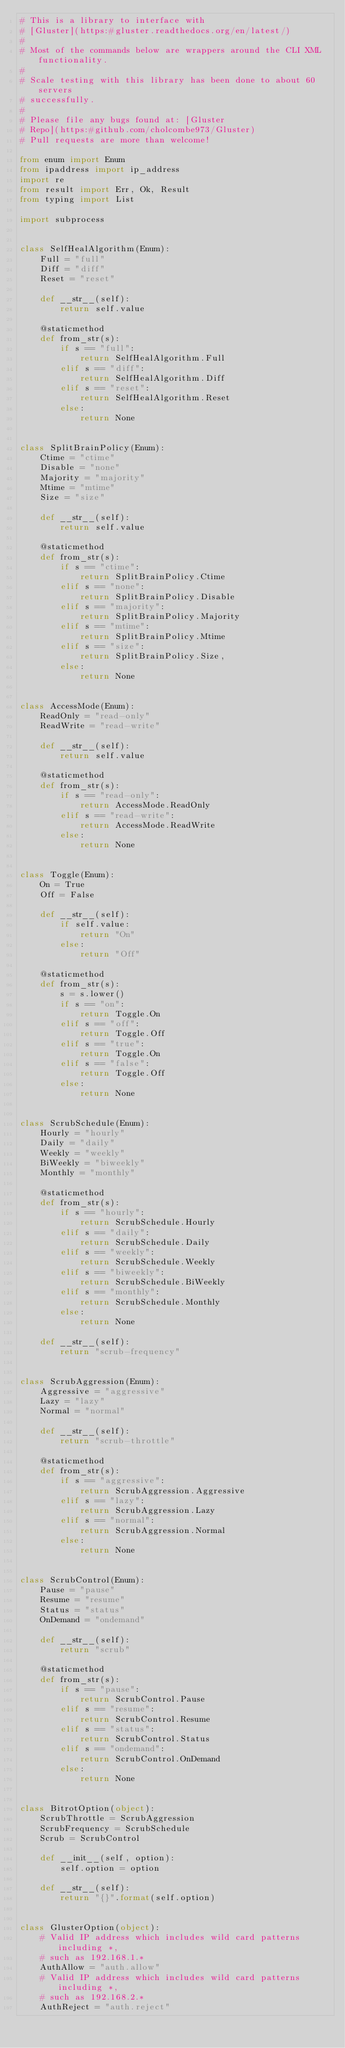Convert code to text. <code><loc_0><loc_0><loc_500><loc_500><_Python_># This is a library to interface with
# [Gluster](https:#gluster.readthedocs.org/en/latest/)
#
# Most of the commands below are wrappers around the CLI XML functionality.
#
# Scale testing with this library has been done to about 60 servers
# successfully.
#
# Please file any bugs found at: [Gluster
# Repo](https:#github.com/cholcombe973/Gluster)
# Pull requests are more than welcome!

from enum import Enum
from ipaddress import ip_address
import re
from result import Err, Ok, Result
from typing import List

import subprocess


class SelfHealAlgorithm(Enum):
    Full = "full"
    Diff = "diff"
    Reset = "reset"

    def __str__(self):
        return self.value

    @staticmethod
    def from_str(s):
        if s == "full":
            return SelfHealAlgorithm.Full
        elif s == "diff":
            return SelfHealAlgorithm.Diff
        elif s == "reset":
            return SelfHealAlgorithm.Reset
        else:
            return None


class SplitBrainPolicy(Enum):
    Ctime = "ctime"
    Disable = "none"
    Majority = "majority"
    Mtime = "mtime"
    Size = "size"

    def __str__(self):
        return self.value

    @staticmethod
    def from_str(s):
        if s == "ctime":
            return SplitBrainPolicy.Ctime
        elif s == "none":
            return SplitBrainPolicy.Disable
        elif s == "majority":
            return SplitBrainPolicy.Majority
        elif s == "mtime":
            return SplitBrainPolicy.Mtime
        elif s == "size":
            return SplitBrainPolicy.Size,
        else:
            return None


class AccessMode(Enum):
    ReadOnly = "read-only"
    ReadWrite = "read-write"

    def __str__(self):
        return self.value

    @staticmethod
    def from_str(s):
        if s == "read-only":
            return AccessMode.ReadOnly
        elif s == "read-write":
            return AccessMode.ReadWrite
        else:
            return None


class Toggle(Enum):
    On = True
    Off = False

    def __str__(self):
        if self.value:
            return "On"
        else:
            return "Off"

    @staticmethod
    def from_str(s):
        s = s.lower()
        if s == "on":
            return Toggle.On
        elif s == "off":
            return Toggle.Off
        elif s == "true":
            return Toggle.On
        elif s == "false":
            return Toggle.Off
        else:
            return None


class ScrubSchedule(Enum):
    Hourly = "hourly"
    Daily = "daily"
    Weekly = "weekly"
    BiWeekly = "biweekly"
    Monthly = "monthly"

    @staticmethod
    def from_str(s):
        if s == "hourly":
            return ScrubSchedule.Hourly
        elif s == "daily":
            return ScrubSchedule.Daily
        elif s == "weekly":
            return ScrubSchedule.Weekly
        elif s == "biweekly":
            return ScrubSchedule.BiWeekly
        elif s == "monthly":
            return ScrubSchedule.Monthly
        else:
            return None

    def __str__(self):
        return "scrub-frequency"


class ScrubAggression(Enum):
    Aggressive = "aggressive"
    Lazy = "lazy"
    Normal = "normal"

    def __str__(self):
        return "scrub-throttle"

    @staticmethod
    def from_str(s):
        if s == "aggressive":
            return ScrubAggression.Aggressive
        elif s == "lazy":
            return ScrubAggression.Lazy
        elif s == "normal":
            return ScrubAggression.Normal
        else:
            return None


class ScrubControl(Enum):
    Pause = "pause"
    Resume = "resume"
    Status = "status"
    OnDemand = "ondemand"

    def __str__(self):
        return "scrub"

    @staticmethod
    def from_str(s):
        if s == "pause":
            return ScrubControl.Pause
        elif s == "resume":
            return ScrubControl.Resume
        elif s == "status":
            return ScrubControl.Status
        elif s == "ondemand":
            return ScrubControl.OnDemand
        else:
            return None


class BitrotOption(object):
    ScrubThrottle = ScrubAggression
    ScrubFrequency = ScrubSchedule
    Scrub = ScrubControl

    def __init__(self, option):
        self.option = option

    def __str__(self):
        return "{}".format(self.option)


class GlusterOption(object):
    # Valid IP address which includes wild card patterns including *,
    # such as 192.168.1.*
    AuthAllow = "auth.allow"
    # Valid IP address which includes wild card patterns including *,
    # such as 192.168.2.*
    AuthReject = "auth.reject"</code> 